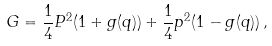<formula> <loc_0><loc_0><loc_500><loc_500>G = \frac { 1 } { 4 } P ^ { 2 } ( 1 + g ( q ) ) + \frac { 1 } { 4 } p ^ { 2 } ( 1 - g ( q ) ) \, ,</formula> 